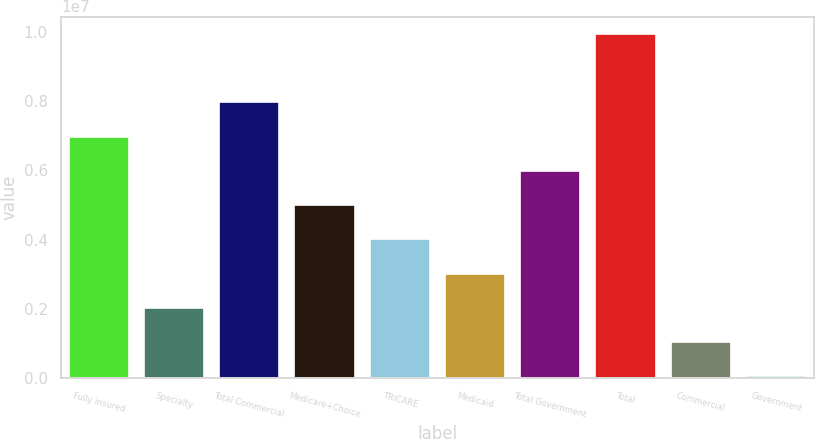<chart> <loc_0><loc_0><loc_500><loc_500><bar_chart><fcel>Fully insured<fcel>Specialty<fcel>Total Commercial<fcel>Medicare+Choice<fcel>TRICARE<fcel>Medicaid<fcel>Total Government<fcel>Total<fcel>Commercial<fcel>Government<nl><fcel>6.97314e+06<fcel>2.0301e+06<fcel>7.96175e+06<fcel>4.99592e+06<fcel>4.00732e+06<fcel>3.01871e+06<fcel>5.98453e+06<fcel>9.93896e+06<fcel>1.04149e+06<fcel>52886<nl></chart> 